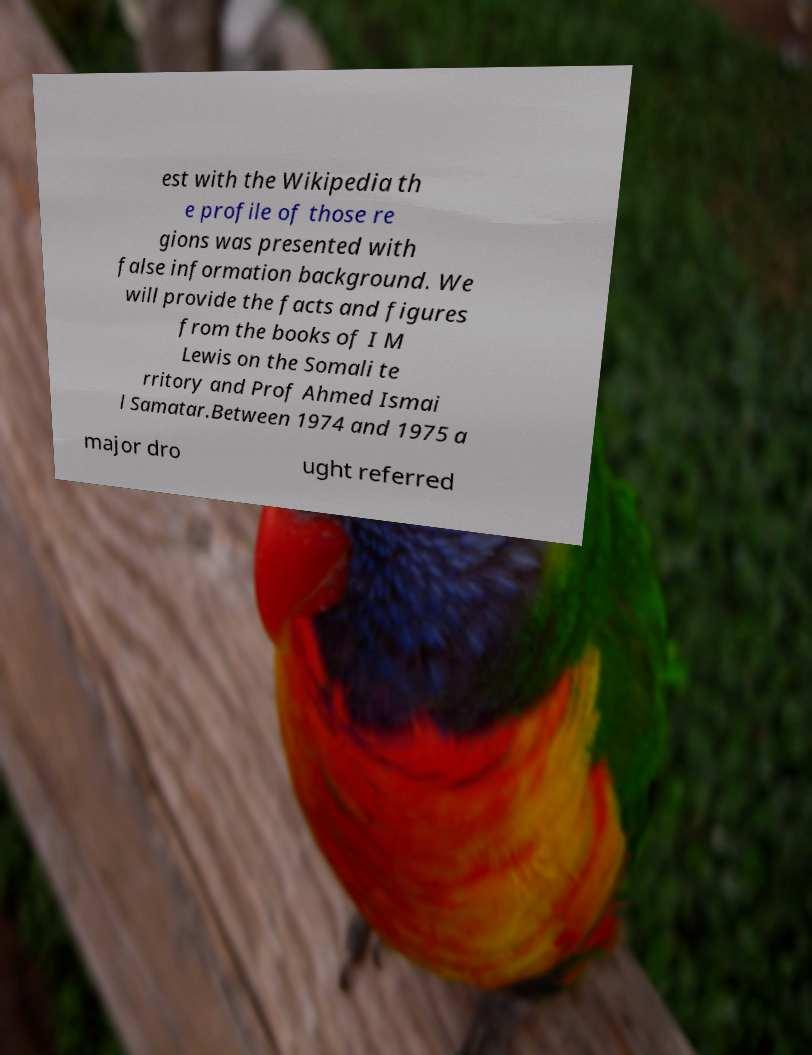Can you read and provide the text displayed in the image?This photo seems to have some interesting text. Can you extract and type it out for me? est with the Wikipedia th e profile of those re gions was presented with false information background. We will provide the facts and figures from the books of I M Lewis on the Somali te rritory and Prof Ahmed Ismai l Samatar.Between 1974 and 1975 a major dro ught referred 